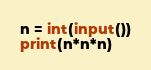Convert code to text. <code><loc_0><loc_0><loc_500><loc_500><_Python_>n = int(input())
print(n*n*n)</code> 